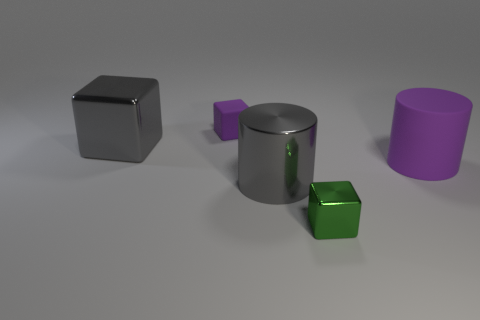Subtract all gray cubes. Subtract all purple balls. How many cubes are left? 2 Add 2 tiny purple rubber objects. How many objects exist? 7 Subtract all cubes. How many objects are left? 2 Add 2 gray metallic blocks. How many gray metallic blocks are left? 3 Add 5 large blue cylinders. How many large blue cylinders exist? 5 Subtract 1 green blocks. How many objects are left? 4 Subtract all small metallic things. Subtract all purple blocks. How many objects are left? 3 